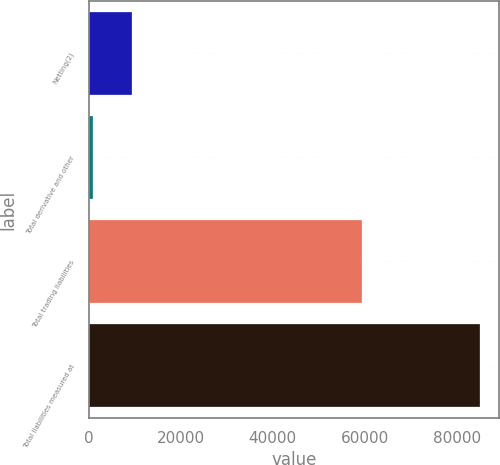Convert chart. <chart><loc_0><loc_0><loc_500><loc_500><bar_chart><fcel>Netting(2)<fcel>Total derivative and other<fcel>Total trading liabilities<fcel>Total liabilities measured at<nl><fcel>9355.5<fcel>946<fcel>59412<fcel>85041<nl></chart> 